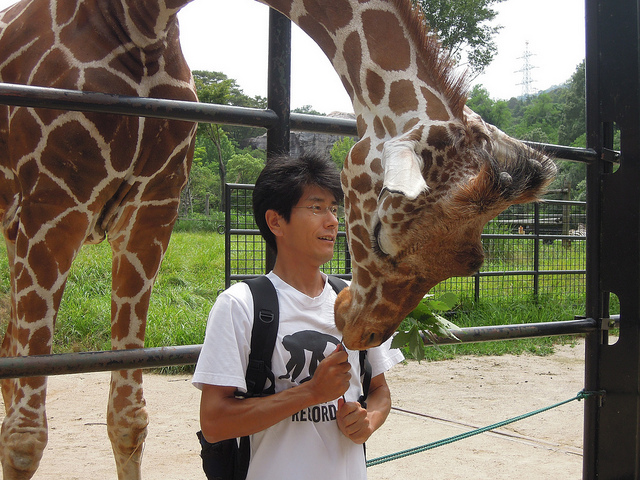Read and extract the text from this image. RECORD 